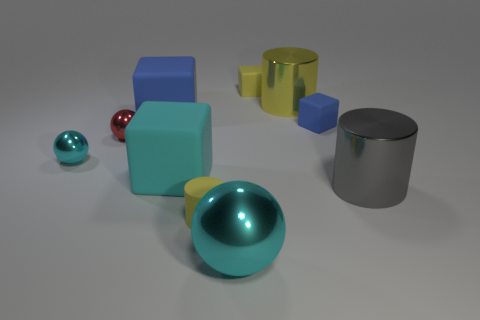What number of blue things are there?
Your response must be concise. 2. There is a rubber block that is behind the blue block behind the blue rubber object to the right of the small yellow block; what is its color?
Offer a terse response. Yellow. Do the large shiny sphere and the small cylinder have the same color?
Provide a succinct answer. No. What number of tiny matte things are on the left side of the yellow metallic thing and behind the red ball?
Keep it short and to the point. 1. What number of metal things are cylinders or large cyan cubes?
Provide a succinct answer. 2. What material is the cyan ball on the left side of the cyan shiny ball in front of the big gray shiny thing?
Provide a succinct answer. Metal. The rubber thing that is the same color as the rubber cylinder is what shape?
Your answer should be very brief. Cube. What shape is the blue object that is the same size as the yellow rubber cube?
Keep it short and to the point. Cube. Are there fewer big blue metal blocks than tiny yellow objects?
Offer a very short reply. Yes. Are there any yellow matte cylinders to the right of the yellow rubber object that is behind the tiny blue matte block?
Offer a very short reply. No. 